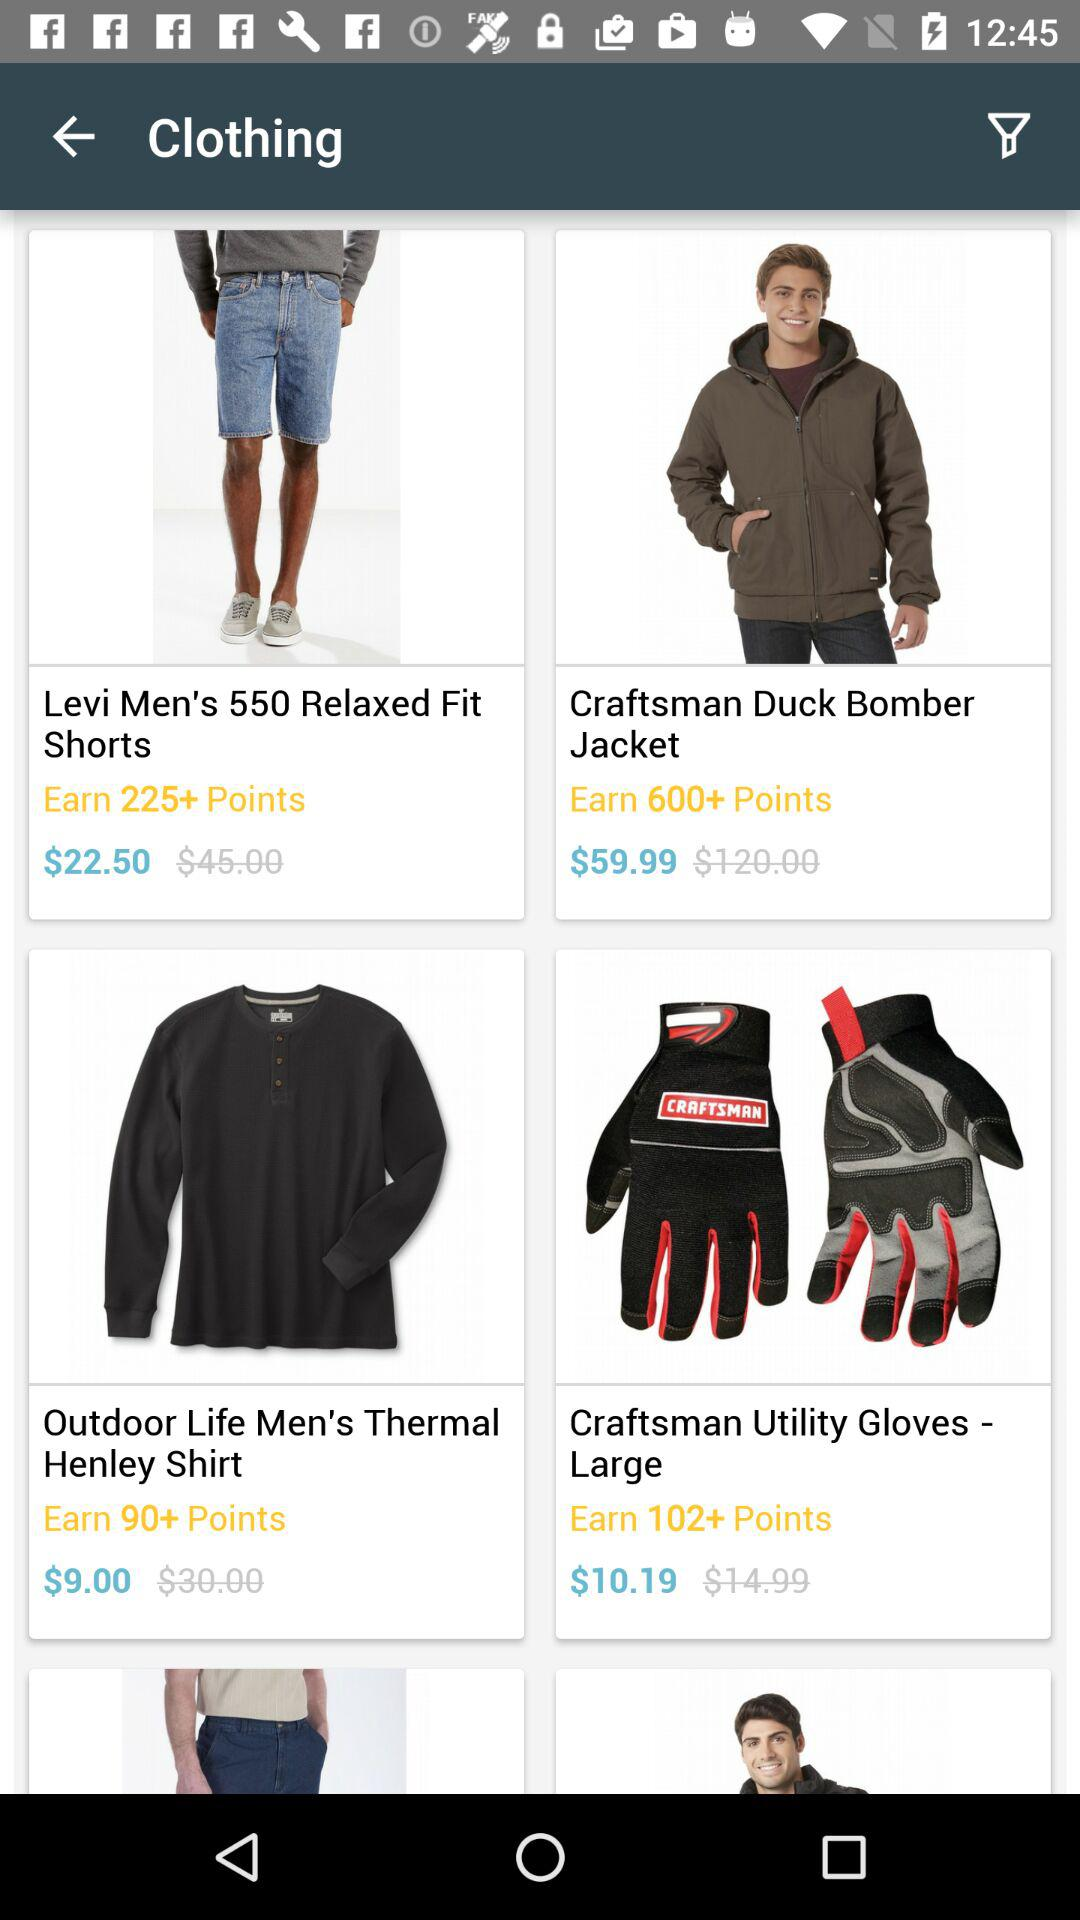How many more points can I earn by buying the craftsman duck bomber jacket than the levi men's 550 relaxed fit shorts?
Answer the question using a single word or phrase. 375 